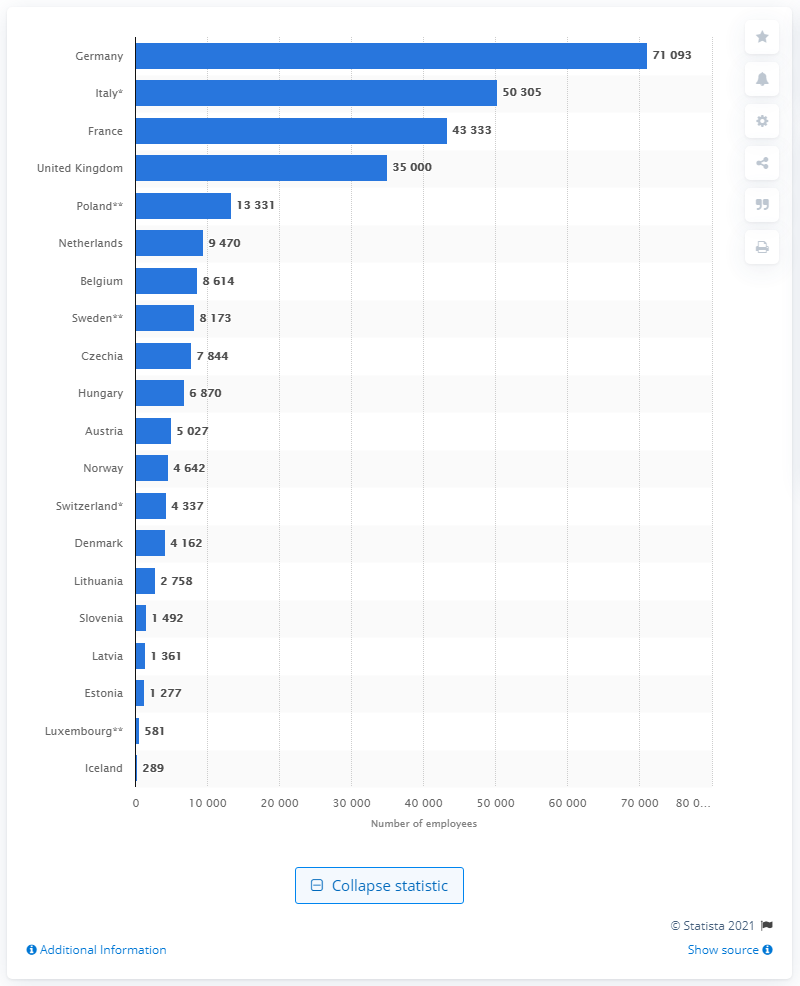Indicate a few pertinent items in this graphic. In 2018, there were 71,093 dentists practicing in Germany. 